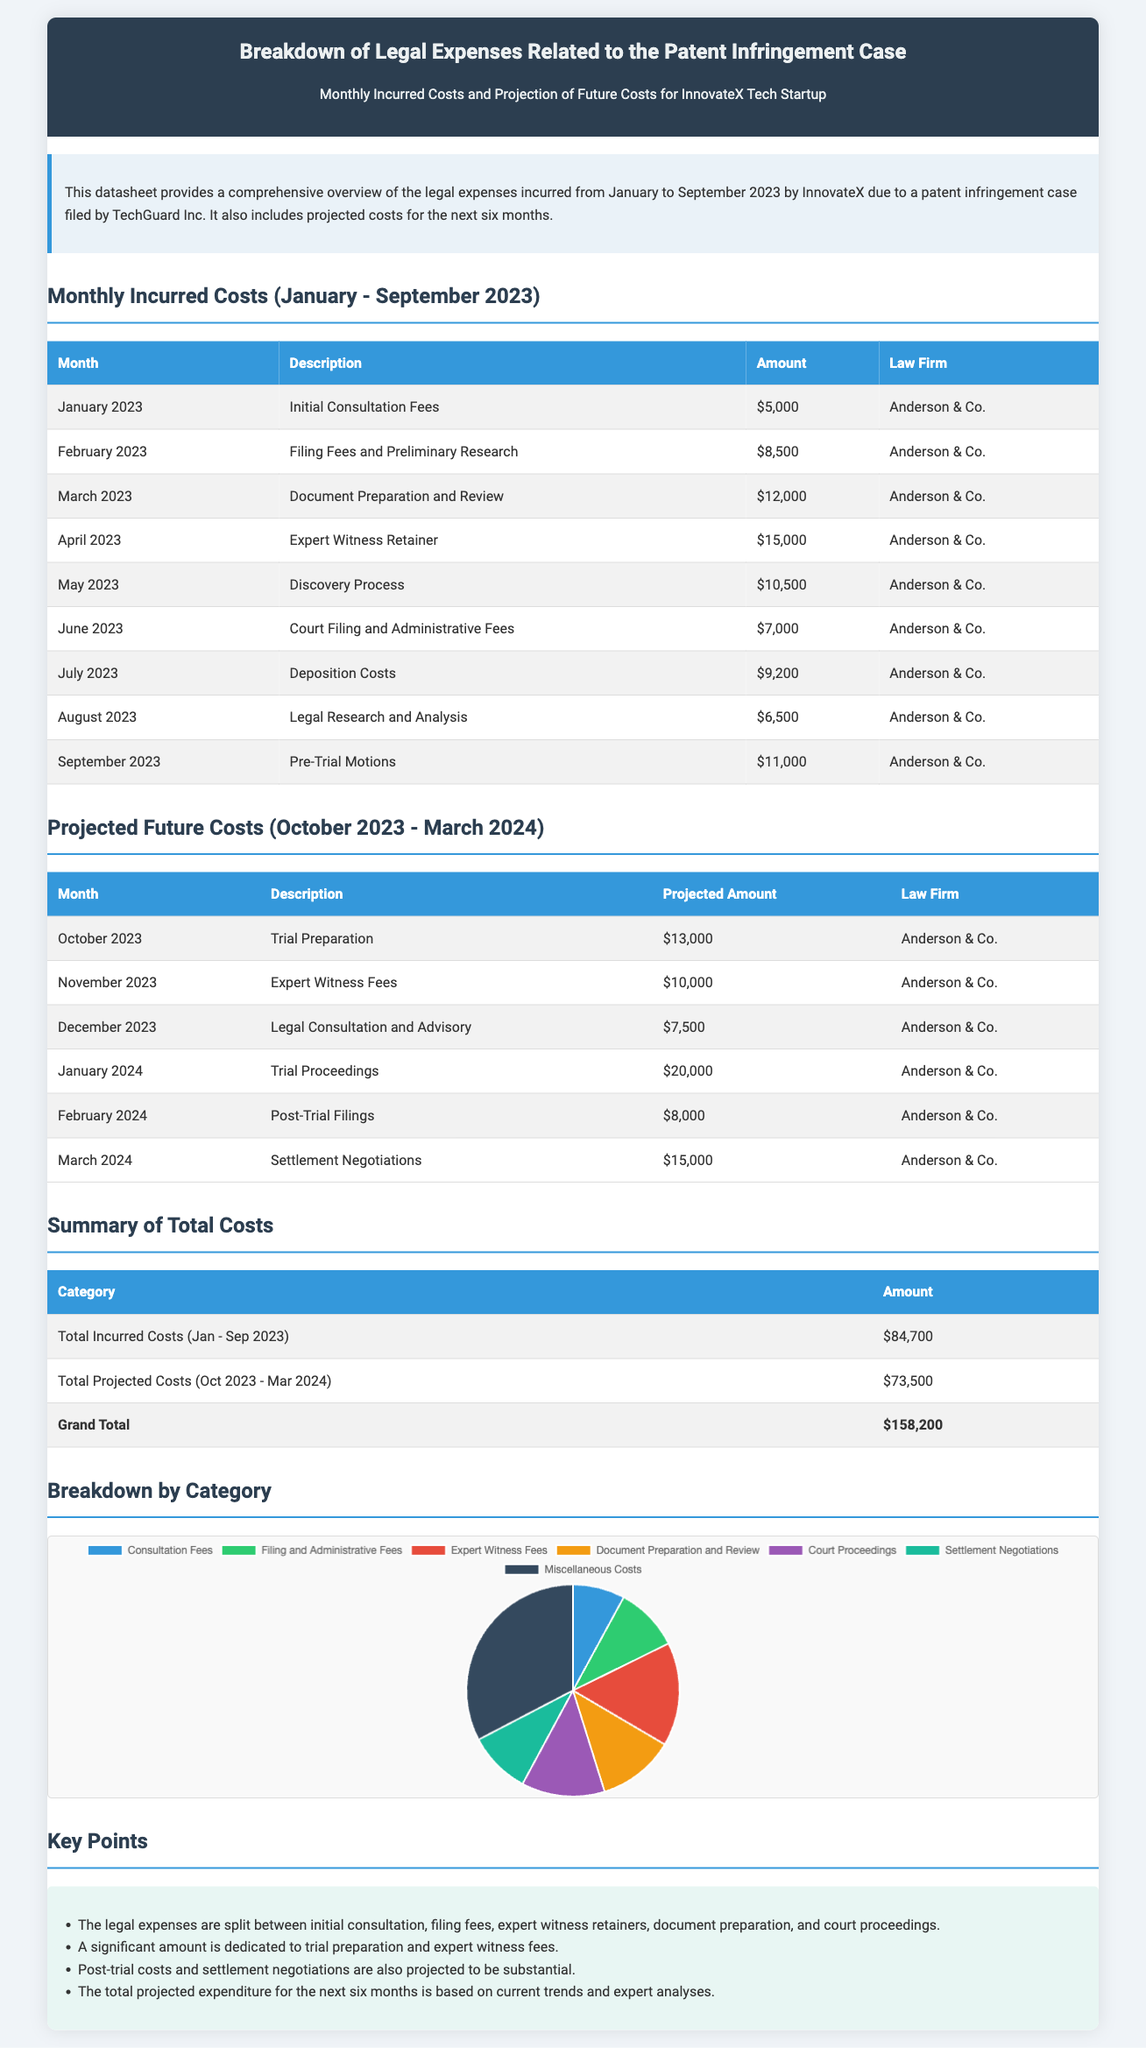What was the total incurred cost from January to September 2023? The total incurred cost is provided in the summary section of the document and it lists the amount as $84,700.
Answer: $84,700 What is the projected cost for January 2024? The projected cost for January 2024 is stated in the future costs table, which shows the amount as $20,000.
Answer: $20,000 Who is the law firm handling the case? The law firm mentioned throughout the document for handling the case is Anderson & Co.
Answer: Anderson & Co Which month had the highest legal expense incurred? By reviewing the monthly incurred costs, April 2023 had the highest legal expense at $15,000 for the expert witness retainer.
Answer: April 2023 What is the total projected cost for the next six months? The total projected cost is summarized in the total costs section, which indicates it as $73,500.
Answer: $73,500 What type of legal expense is projected for March 2024? The projected legal expense for March 2024 is for settlement negotiations as mentioned in the future costs table.
Answer: Settlement Negotiations How much was spent on court filing and administrative fees in June 2023? The specific amount for court filing and administrative fees is listed under June 2023, which is $7,000.
Answer: $7,000 What is the total grand cost including both incurred and projected expenses? The document summarizes the grand total of costs, which includes incurred and projected expenses is $158,200.
Answer: $158,200 What is a key point mentioned regarding future costs? One key point noted in the document states that future costs for post-trial and settlement negotiations are expected to be substantial.
Answer: Substantial 